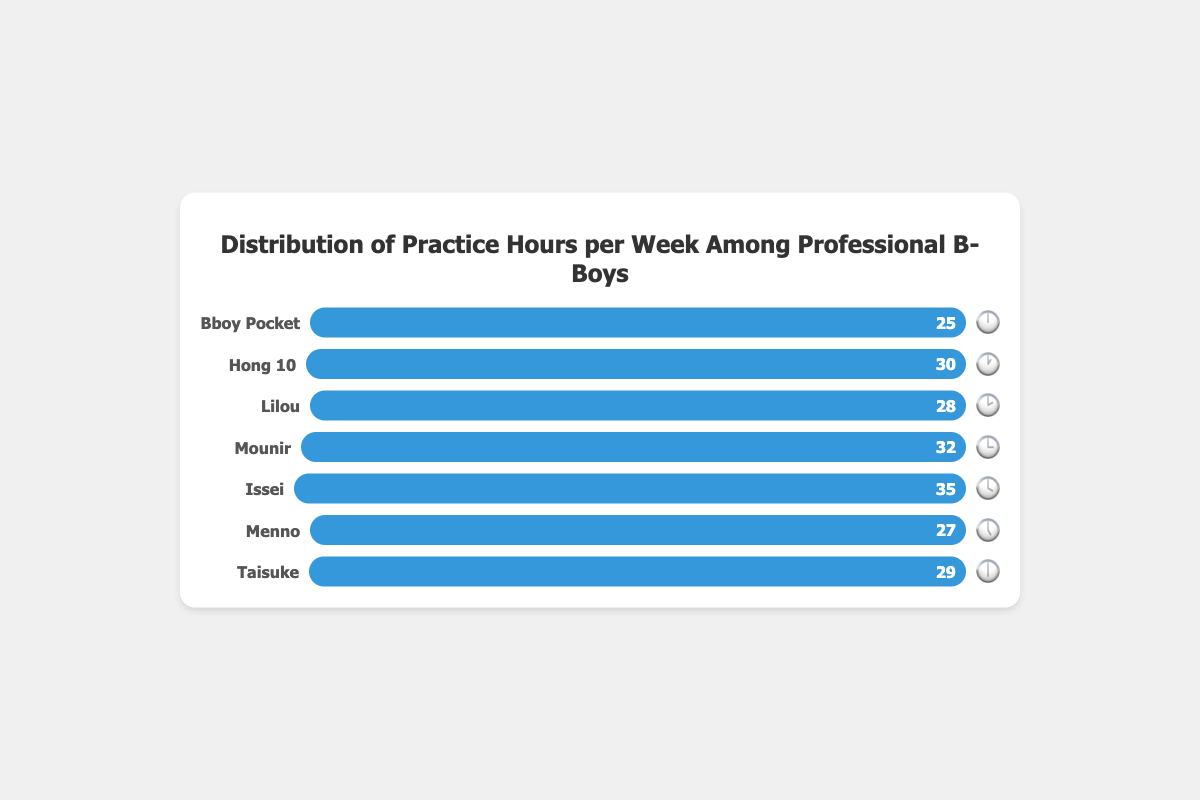what's the title of the chart? The title of the chart is centered at the top of the chart container and reads "Distribution of Practice Hours per Week Among Professional B-Boys".
Answer: Distribution of Practice Hours per Week Among Professional B-Boys which b-boy practices the most hours per week? By comparing the lengths of the horizontal bars, the longest bar belongs to Issei with 35 hours.
Answer: Issei what's the total number of practice hours for Lilou and Taisuke combined? Lilou practices 28 hours and Taisuke practices 29 hours. Summing these together, 28 + 29 = 57 hours.
Answer: 57 what's the average number of practice hours among all the b-boys? Sum the practice hours for all b-boys: 25 + 30 + 28 + 32 + 35 + 27 + 29 = 206 hours. Divide by the number of b-boys (7) to get 206 / 7 ≈ 29.43 hours.
Answer: 29.43 how many b-boys practice more than 28 hours per week? B-boys who practice more than 28 hours are Hong 10 (30), Mounir (32), Issei (35), and Taisuke (29). This makes a total of 4 b-boys.
Answer: 4 which b-boy practices the least given his clock emoji? The shortest bar belongs to Bboy Pocket, tagged with emoji 🕛, and he practices 25 hours.
Answer: Bboy Pocket 🕛 what is the difference in practice hours between Menno and Hong 10? Menno practices 27 hours and Hong 10 practices 30 hours. The difference is 30 - 27 = 3 hours.
Answer: 3 what's the median value of practice hours among all the b-boys? Ordering the practice hours: 25, 27, 28, 29, 30, 32, 35, the middle value (4th) is 29 hours.
Answer: 29 who practices exactly 30 hours and what's their clock emoji? By checking the bar labeled 30 hours, Hong 10 practices 30 hours and his emoji is 🕐.
Answer: Hong 10 🕐 